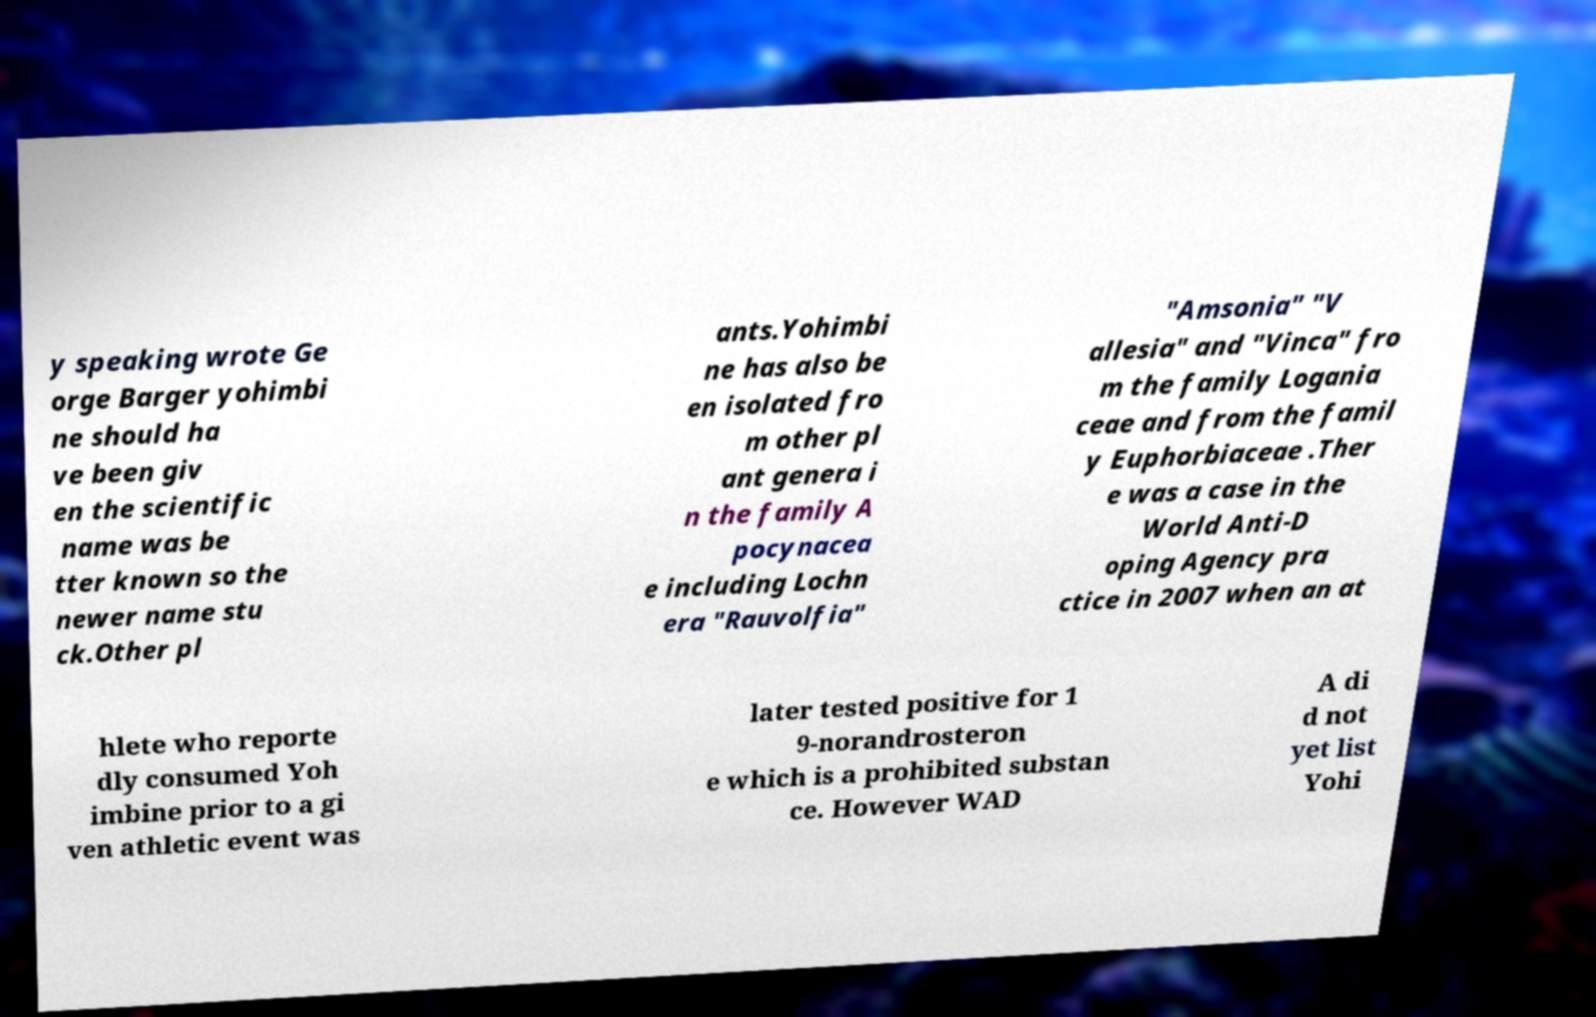Can you accurately transcribe the text from the provided image for me? y speaking wrote Ge orge Barger yohimbi ne should ha ve been giv en the scientific name was be tter known so the newer name stu ck.Other pl ants.Yohimbi ne has also be en isolated fro m other pl ant genera i n the family A pocynacea e including Lochn era "Rauvolfia" "Amsonia" "V allesia" and "Vinca" fro m the family Logania ceae and from the famil y Euphorbiaceae .Ther e was a case in the World Anti-D oping Agency pra ctice in 2007 when an at hlete who reporte dly consumed Yoh imbine prior to a gi ven athletic event was later tested positive for 1 9-norandrosteron e which is a prohibited substan ce. However WAD A di d not yet list Yohi 